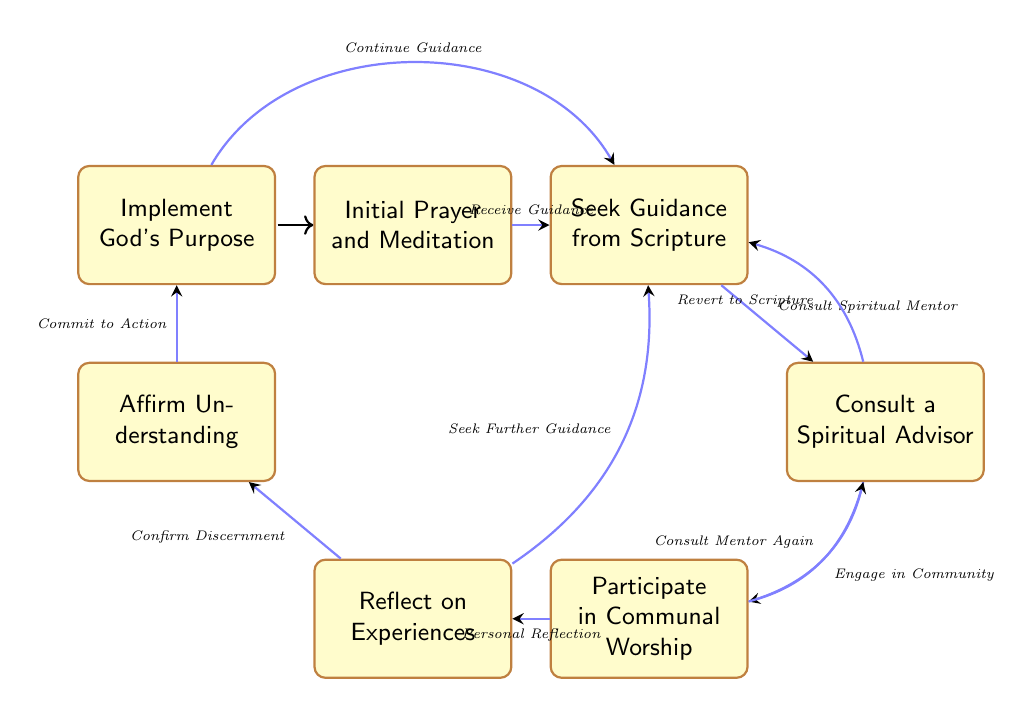What is the first step in the process? The first step in the process, as indicated by the initial node, is "Initial Prayer and Meditation." This can be identified by looking at the starting point of the diagram.
Answer: Initial Prayer and Meditation How many different states are there in the diagram? To find the number of states, we can count all the nodes represented. There are a total of 7 states in this finite state machine: Initial Prayer and Meditation, Seek Guidance from Scripture, Consult a Spiritual Advisor, Participate in Communal Worship, Reflect on Experiences, Affirm Understanding, and Implement God's Purpose.
Answer: 7 What action leads to "Consult a Spiritual Advisor"? The action that leads to "Consult a Spiritual Advisor" is "Consult Spiritual Mentor." This is shown as a transition from the "Seek Guidance from Scripture" state.
Answer: Consult Spiritual Mentor What is the final outcome of the discernment process? The final outcome of the discernment process is "Implement God's Purpose." This is depicted as the last state in the sequence after affirming understanding.
Answer: Implement God's Purpose Which step allows reversion to Scripture? The step that allows reversion to Scripture is "Consult a Spiritual Advisor." This node provides a transition back to "Seek Guidance from Scripture."
Answer: Consult a Spiritual Advisor After "Participate in Communal Worship," what are the two possible transitions? The two possible transitions after "Participate in Communal Worship" are "Personal Reflection" which leads to "Reflect on Experiences" and "Consult Mentor Again" which goes back to "Consult a Spiritual Advisor." This indicates multiple routes can be taken from this state.
Answer: Personal Reflection and Consult Mentor Again What is the action associated with moving from "Affirm Understanding" to "Implement God's Purpose"? The action associated with this transition is "Commit to Action." This action indicates the readiness to put understood divine will into practice.
Answer: Commit to Action 